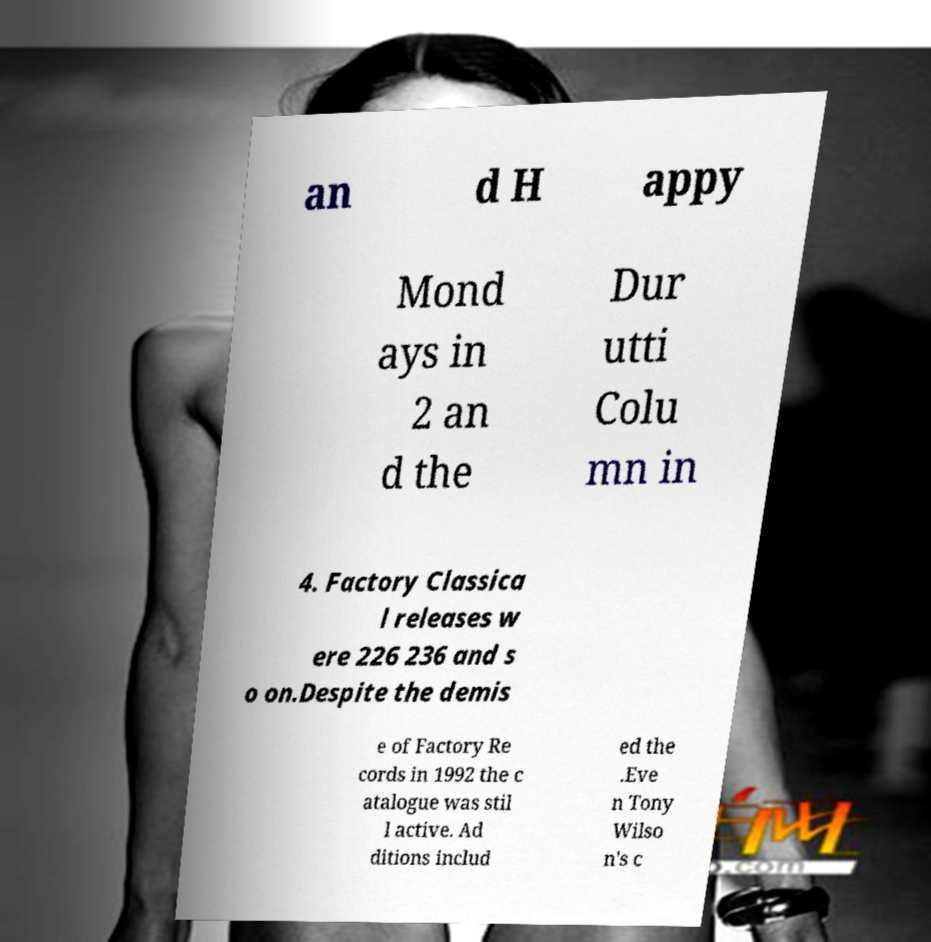Can you accurately transcribe the text from the provided image for me? an d H appy Mond ays in 2 an d the Dur utti Colu mn in 4. Factory Classica l releases w ere 226 236 and s o on.Despite the demis e of Factory Re cords in 1992 the c atalogue was stil l active. Ad ditions includ ed the .Eve n Tony Wilso n's c 